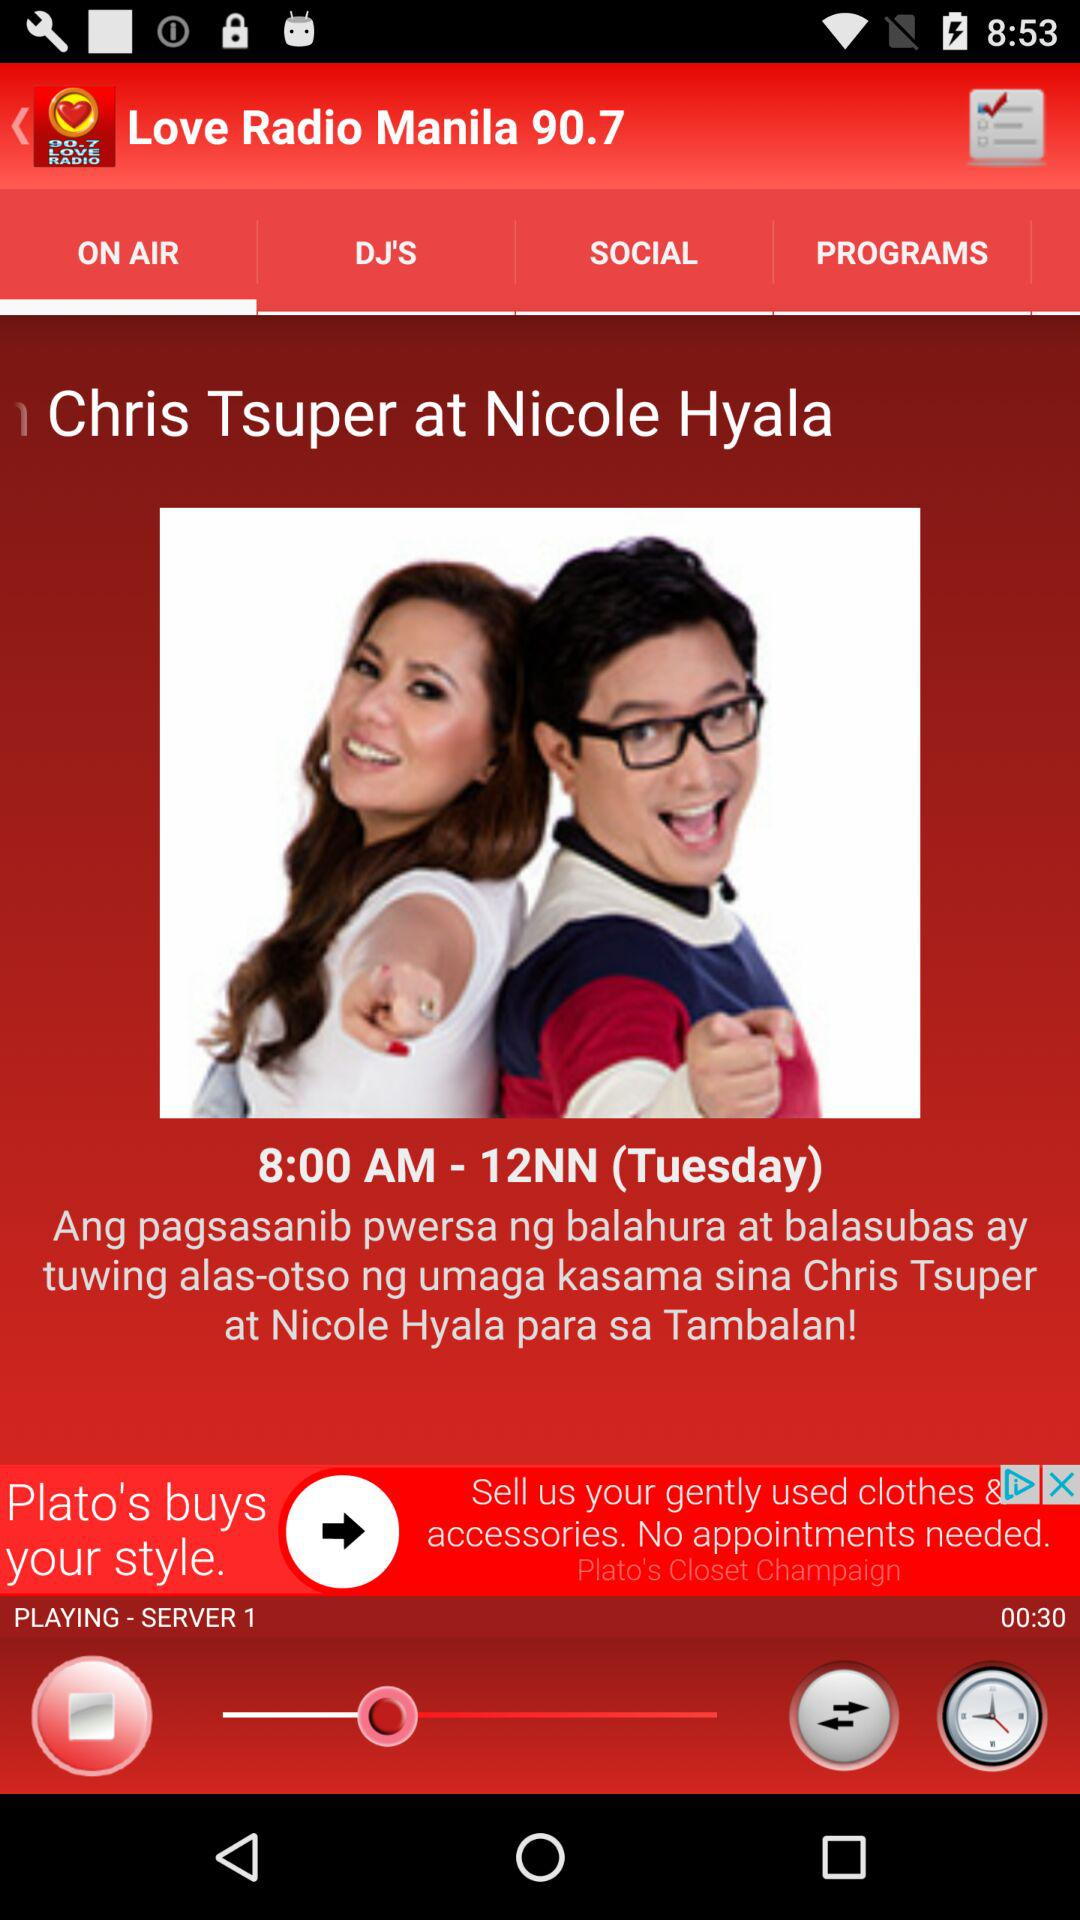What are the timings of the show "Chris Tsuper at Nicole Hyala"? The timing of the show is 8:00 a.m.–12 p.m. 